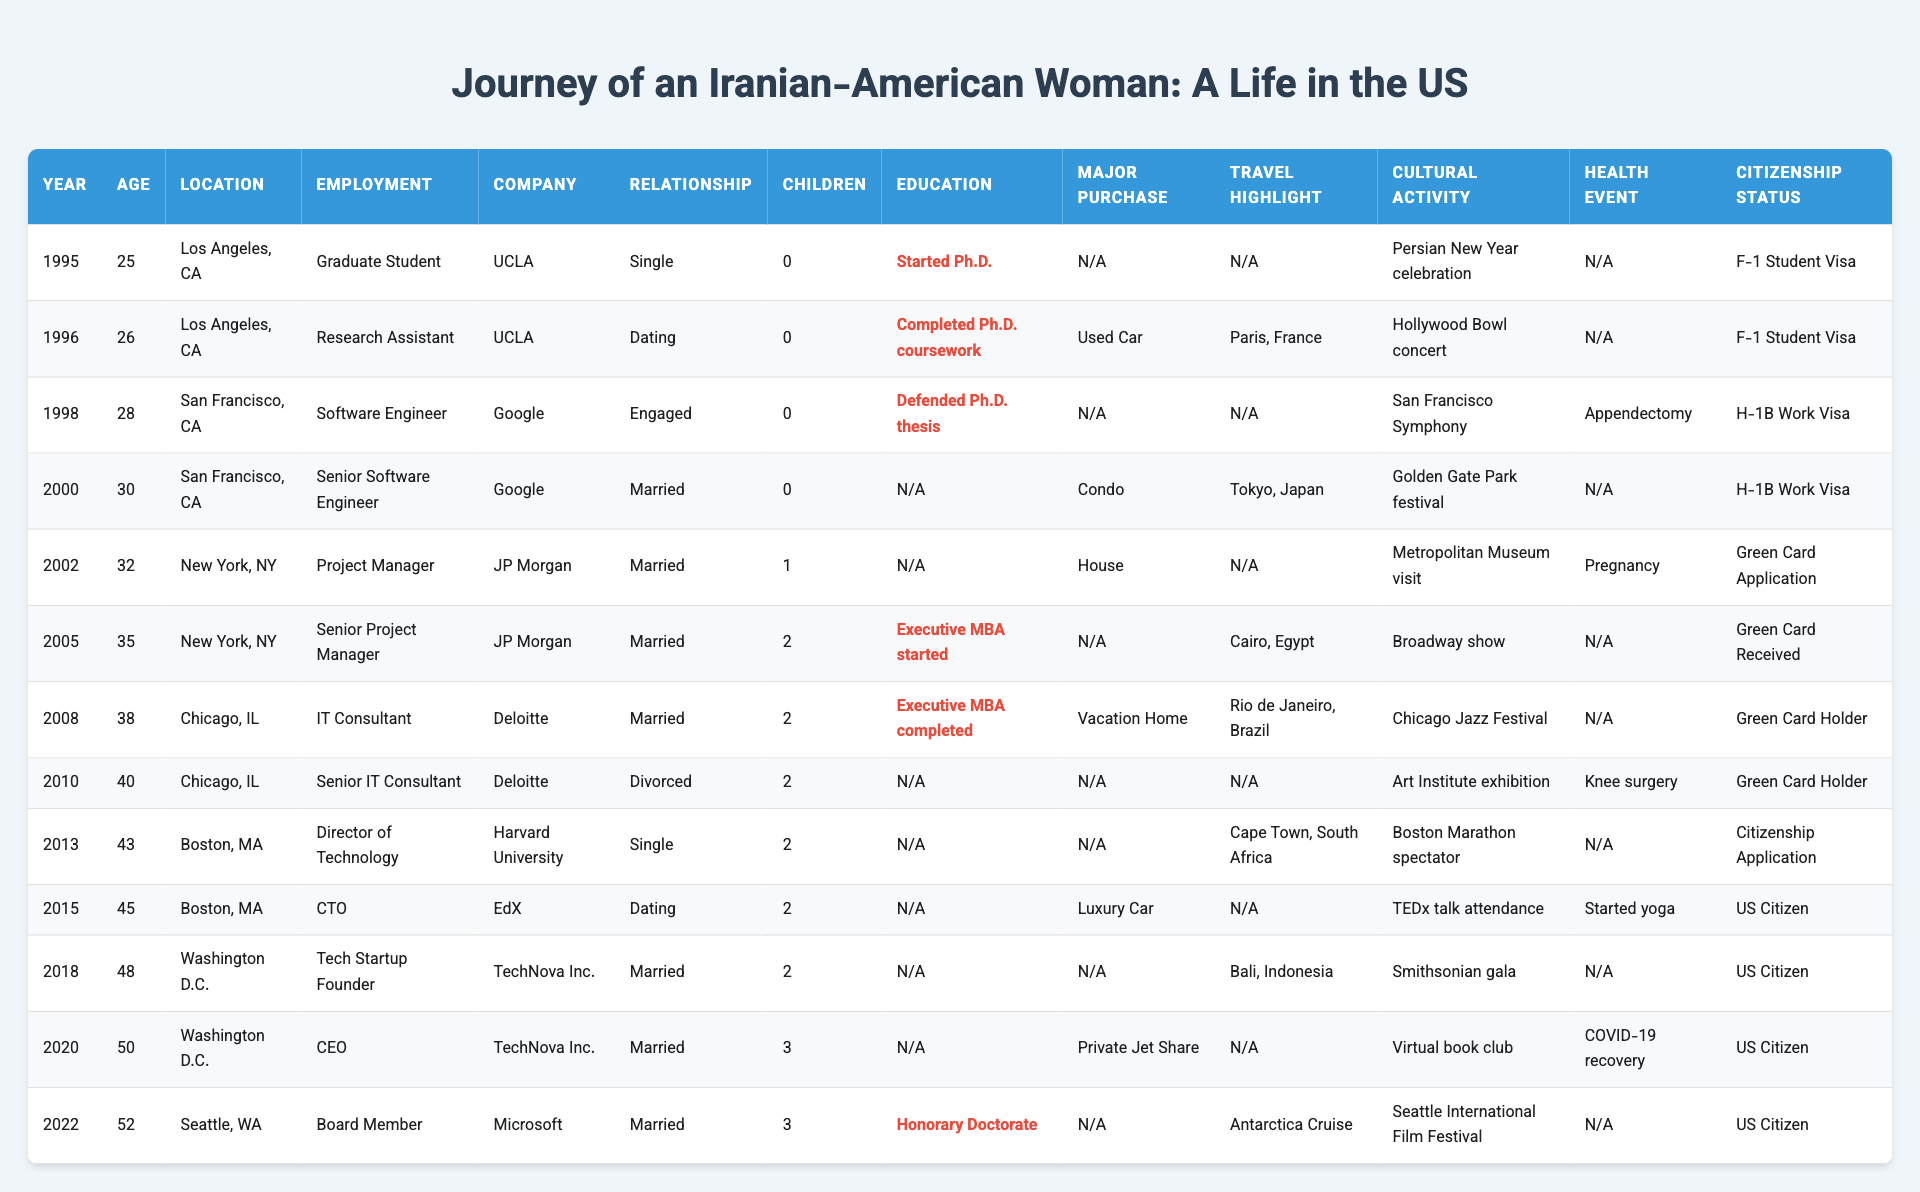What city did you live in when you completed your Ph.D. coursework? You can find the relevant year and education milestone in the table. In 1996, the milestone was the completion of Ph.D. coursework, and the location listed for that year is Los Angeles, CA.
Answer: Los Angeles, CA How many children did you have by 2010? In 2010, the table indicates you had 2 children. You can find this number directly in the "Children" column for that year.
Answer: 2 What was your employment status in 2002? According to the table, in 2002, you were a Project Manager at JP Morgan. This information is found in the respective columns for that year.
Answer: Project Manager Was there a year when you had a major health event? Yes, the table shows that an appendectomy occurred in 1998 and knee surgery in 2008. Both of these events are noted under the "Health Event" column.
Answer: Yes In which location did you celebrate the Persian New Year? The table states that in 1995, you celebrated the Persian New Year in Los Angeles, CA. This event is recorded under the "Cultural Activity" column for that year.
Answer: Los Angeles, CA What percentage of the years listed shows you being married? Counting the years where your relationship status was "Married" (1998, 2000, 2002, 2005, 2006, 2010, 2015, 2018, and 2020), there are 9 years of a total of 13 years. Therefore, (9/13) * 100 = 69.23%, so about 69%.
Answer: 69% Which year did you travel to the largest number of countries? The table indicates that many travel highlights included trips to multiple countries. The most evident is in 2022, where you took an Antarctica Cruise, highlighting more extensive travel experiences, although assessable in fewer instances overall. Considering this requires context to some degree, more years could reference singular but notable travels.
Answer: 2022 How did your relationship status change in 2010? According to the table, in 2010 you transitioned from being married to divorced. You can see the relationship status change at that point in the timeline.
Answer: Divorced What is the significance of the year 2013 in terms of your career? In 2013, you were promoted to Director of Technology at Harvard University, which signifies a substantial advancement in your career, indicating an increase in responsibility and leadership.
Answer: Director of Technology When did you first become a US citizen? The data notes that you became a US Citizen in 2015. This status is found in the "Citizenship Status" column for that specific year.
Answer: 2015 What was your age in the year you completed your Executive MBA? You completed your Executive MBA in 2008, and your age at that time was 38, referencing the "Age" column aligned with the completion milestone.
Answer: 38 